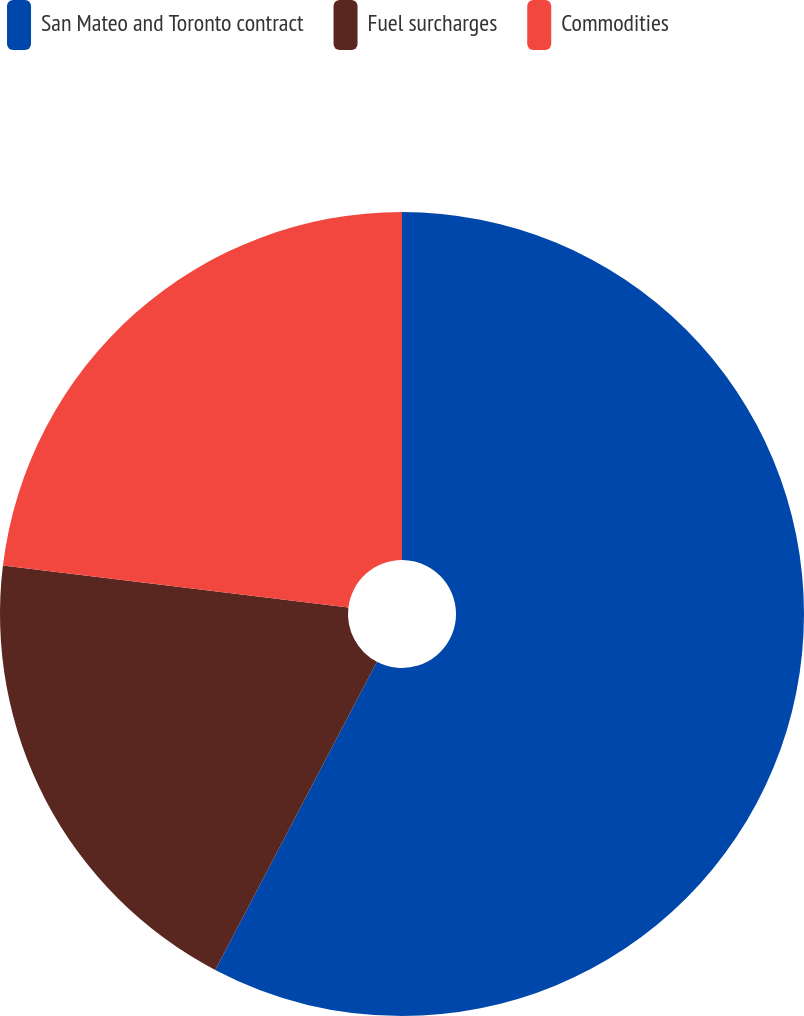Convert chart to OTSL. <chart><loc_0><loc_0><loc_500><loc_500><pie_chart><fcel>San Mateo and Toronto contract<fcel>Fuel surcharges<fcel>Commodities<nl><fcel>57.69%<fcel>19.23%<fcel>23.08%<nl></chart> 